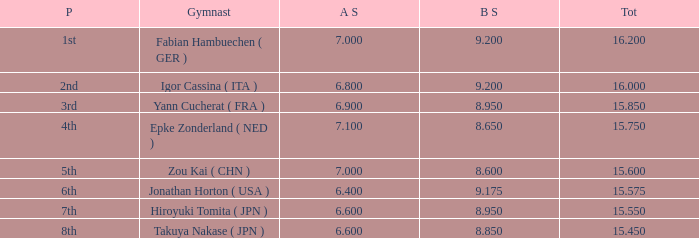Which gymnast had a b score of 8.95 and an a score less than 6.9 Hiroyuki Tomita ( JPN ). 